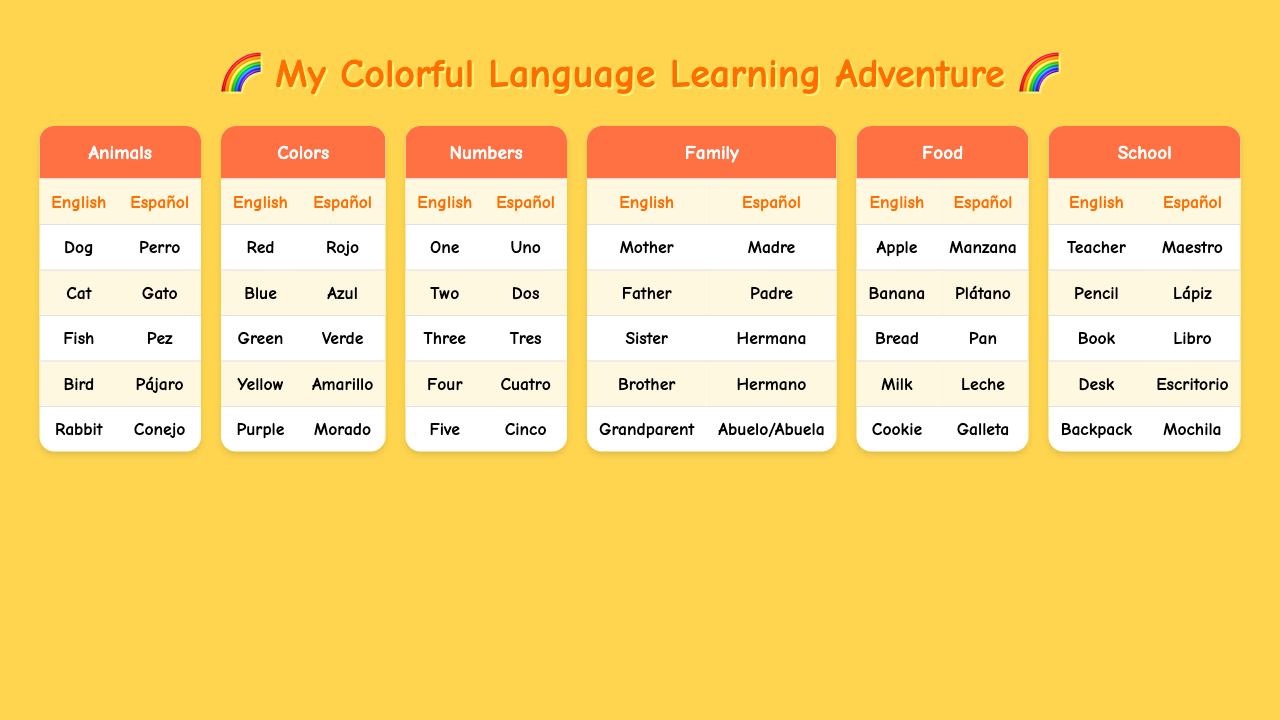What is the Spanish word for "Dog"? In the Animals category, "Dog" corresponds to the Spanish word "Perro".
Answer: Perro How many colors are listed in the table? The Colors category lists 5 colors: Red, Blue, Green, Yellow, and Purple. Therefore, there are 5 colors.
Answer: 5 What is the Spanish translation of "Milk"? In the Food category, "Milk" is translated to "Leche".
Answer: Leche Do all family members have unique English words? Yes, in the Family category, each member (Mother, Father, Sister, Brother, Grandparent) has a unique English word.
Answer: Yes Which animal's Spanish translation starts with a "C"? The Animals category contains "Conejo," which is the Spanish word for "Rabbit," and it starts with "C".
Answer: Conejo What is the total number of animal terms in the table? The Animals category includes 5 terms: Dog, Cat, Fish, Bird, and Rabbit. So, the total is 5.
Answer: 5 Is "Plátano" the Spanish word for "Banana"? Yes, according to the Food category, "Plátano" is indeed the Spanish word for "Banana".
Answer: Yes If you were to count all the words in the Colors and Family categories, how many would you have? The Colors category has 5 words and the Family category has 5 words, so the total is 5 + 5 = 10.
Answer: 10 Which color has the Spanish translation "Verde"? "Verde" corresponds to "Green" in the Colors category.
Answer: Green Which category has the term "Maestro"? "Maestro" is found in the School category as the Spanish word for "Teacher".
Answer: School 